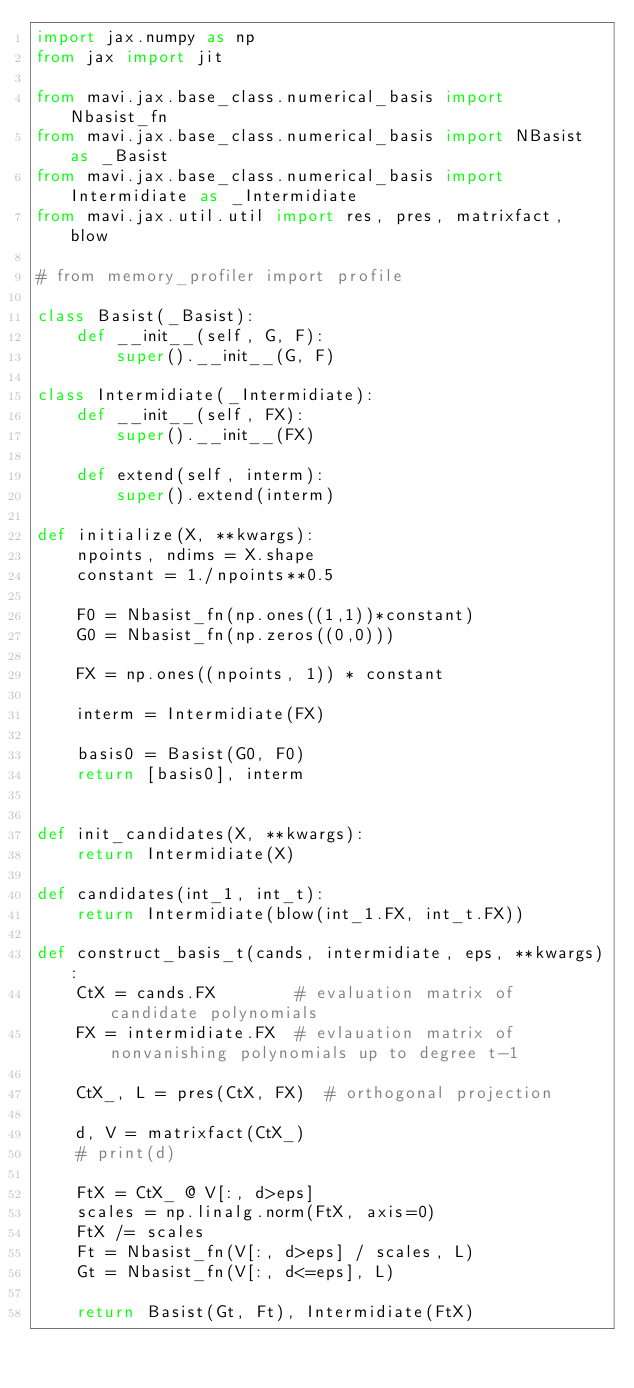Convert code to text. <code><loc_0><loc_0><loc_500><loc_500><_Python_>import jax.numpy as np
from jax import jit 

from mavi.jax.base_class.numerical_basis import Nbasist_fn
from mavi.jax.base_class.numerical_basis import NBasist as _Basist
from mavi.jax.base_class.numerical_basis import Intermidiate as _Intermidiate
from mavi.jax.util.util import res, pres, matrixfact, blow

# from memory_profiler import profile

class Basist(_Basist):
    def __init__(self, G, F):
        super().__init__(G, F)

class Intermidiate(_Intermidiate):
    def __init__(self, FX):
        super().__init__(FX)

    def extend(self, interm):
        super().extend(interm)

def initialize(X, **kwargs):
    npoints, ndims = X.shape
    constant = 1./npoints**0.5

    F0 = Nbasist_fn(np.ones((1,1))*constant)
    G0 = Nbasist_fn(np.zeros((0,0)))

    FX = np.ones((npoints, 1)) * constant

    interm = Intermidiate(FX)

    basis0 = Basist(G0, F0)
    return [basis0], interm


def init_candidates(X, **kwargs):
    return Intermidiate(X)

def candidates(int_1, int_t):
    return Intermidiate(blow(int_1.FX, int_t.FX))

def construct_basis_t(cands, intermidiate, eps, **kwargs):
    CtX = cands.FX        # evaluation matrix of candidate polynomials
    FX = intermidiate.FX  # evlauation matrix of nonvanishing polynomials up to degree t-1

    CtX_, L = pres(CtX, FX)  # orthogonal projection

    d, V = matrixfact(CtX_)
    # print(d)

    FtX = CtX_ @ V[:, d>eps]
    scales = np.linalg.norm(FtX, axis=0)
    FtX /= scales
    Ft = Nbasist_fn(V[:, d>eps] / scales, L)
    Gt = Nbasist_fn(V[:, d<=eps], L)

    return Basist(Gt, Ft), Intermidiate(FtX)</code> 